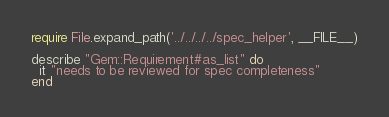<code> <loc_0><loc_0><loc_500><loc_500><_Ruby_>require File.expand_path('../../../../spec_helper', __FILE__)

describe "Gem::Requirement#as_list" do
  it "needs to be reviewed for spec completeness"
end
</code> 